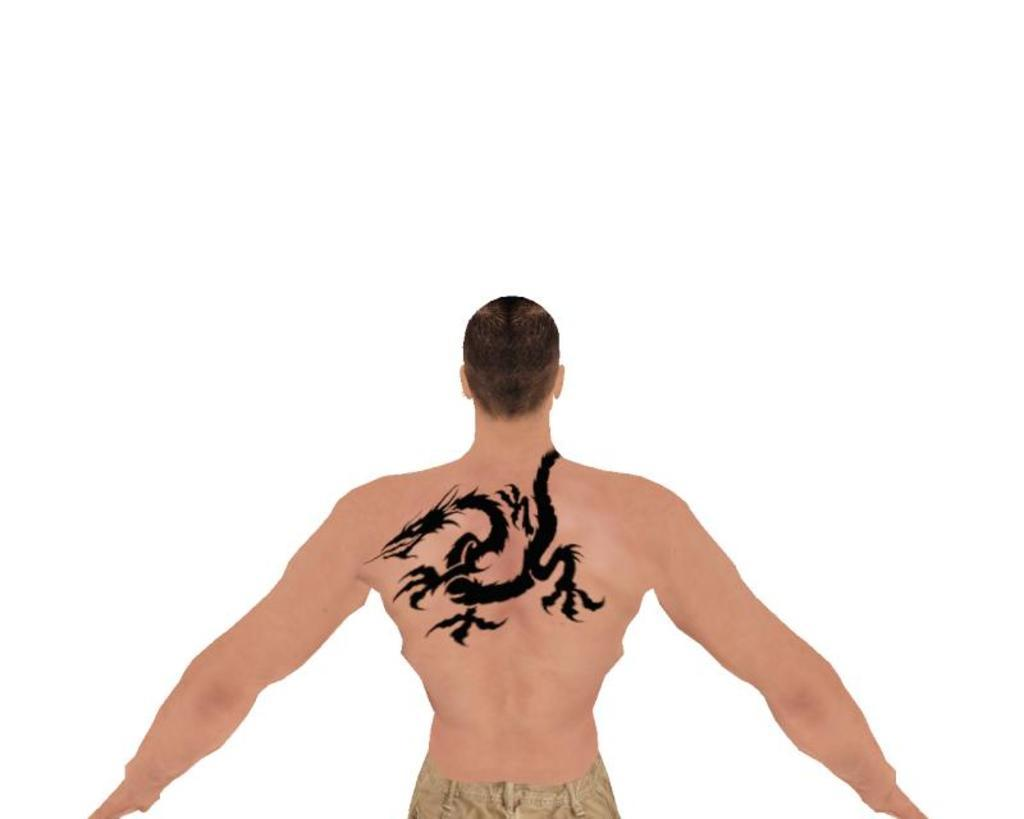What is present in the image? There is a person in the image. Can you describe any distinguishing features of the person? The person has a tattoo. What is the color of the background in the image? The background of the image is white. How many toads can be seen in the image? There are no toads present in the image. What type of chin does the person have in the image? The image does not provide enough detail to describe the person's chin. 